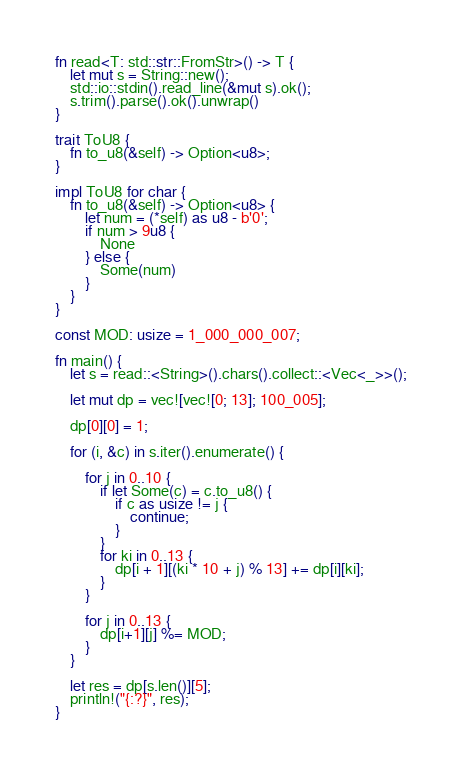Convert code to text. <code><loc_0><loc_0><loc_500><loc_500><_Rust_>fn read<T: std::str::FromStr>() -> T {
    let mut s = String::new();
    std::io::stdin().read_line(&mut s).ok();
    s.trim().parse().ok().unwrap()
}

trait ToU8 {
    fn to_u8(&self) -> Option<u8>;
}

impl ToU8 for char {
    fn to_u8(&self) -> Option<u8> {
        let num = (*self) as u8 - b'0';
        if num > 9u8 {
            None
        } else {
            Some(num)
        }
    }
}

const MOD: usize = 1_000_000_007;

fn main() {
    let s = read::<String>().chars().collect::<Vec<_>>();

    let mut dp = vec![vec![0; 13]; 100_005];

    dp[0][0] = 1;

    for (i, &c) in s.iter().enumerate() {
        
        for j in 0..10 {
            if let Some(c) = c.to_u8() {
                if c as usize != j {
                    continue;
                }
            }
            for ki in 0..13 {
                dp[i + 1][(ki * 10 + j) % 13] += dp[i][ki];
            }
        }

        for j in 0..13 {
            dp[i+1][j] %= MOD;
        }
    }

    let res = dp[s.len()][5];
    println!("{:?}", res);
}
</code> 